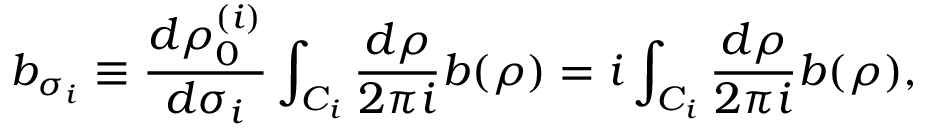<formula> <loc_0><loc_0><loc_500><loc_500>b _ { \sigma _ { i } } \equiv \frac { d \rho _ { 0 } ^ { ( i ) } } { d \sigma _ { i } } \int _ { C _ { i } } { \frac { d \rho } { 2 \pi i } } b ( \rho ) = i \int _ { C _ { i } } { \frac { d \rho } { 2 \pi i } } b ( \rho ) ,</formula> 